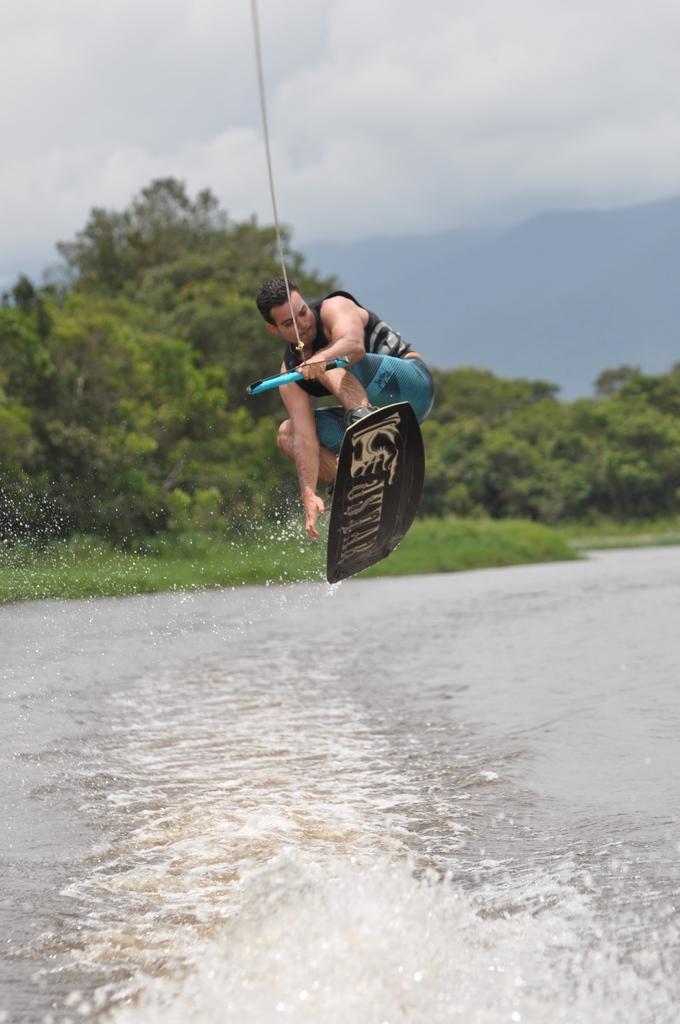In one or two sentences, can you explain what this image depicts? In the center of the image we can see a person on a surfboard holding a stick with rope, we can also see water, group of trees, plants and hills. At the top of the image we can see the sky. 